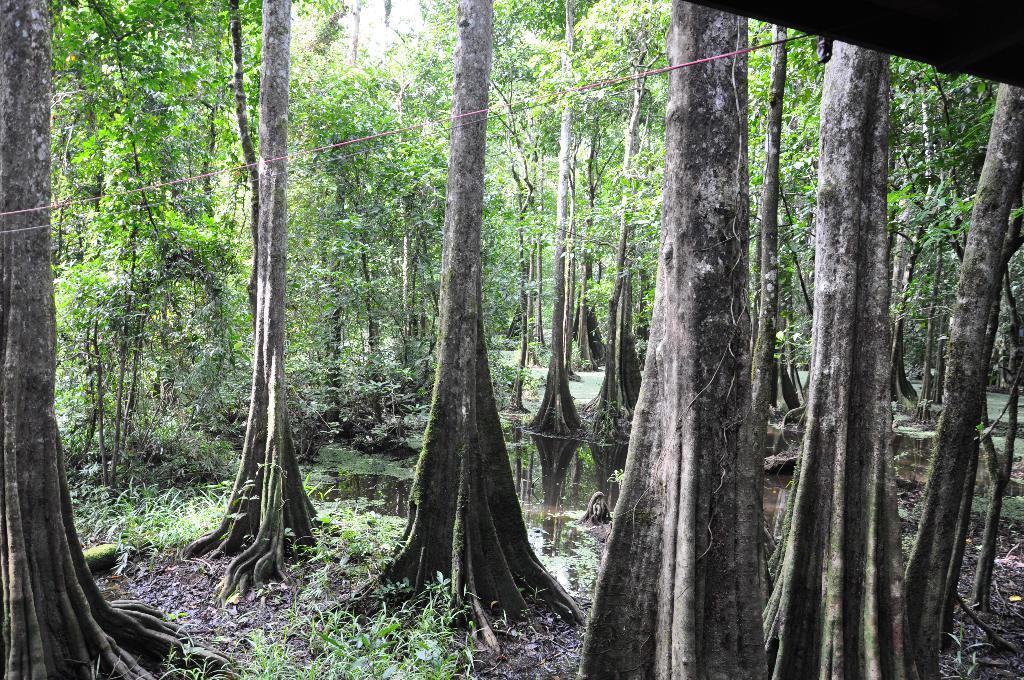How would you summarize this image in a sentence or two? In this picture we can observe trees and plants on the ground. There is some water. We can observe red color wire in this picture. 